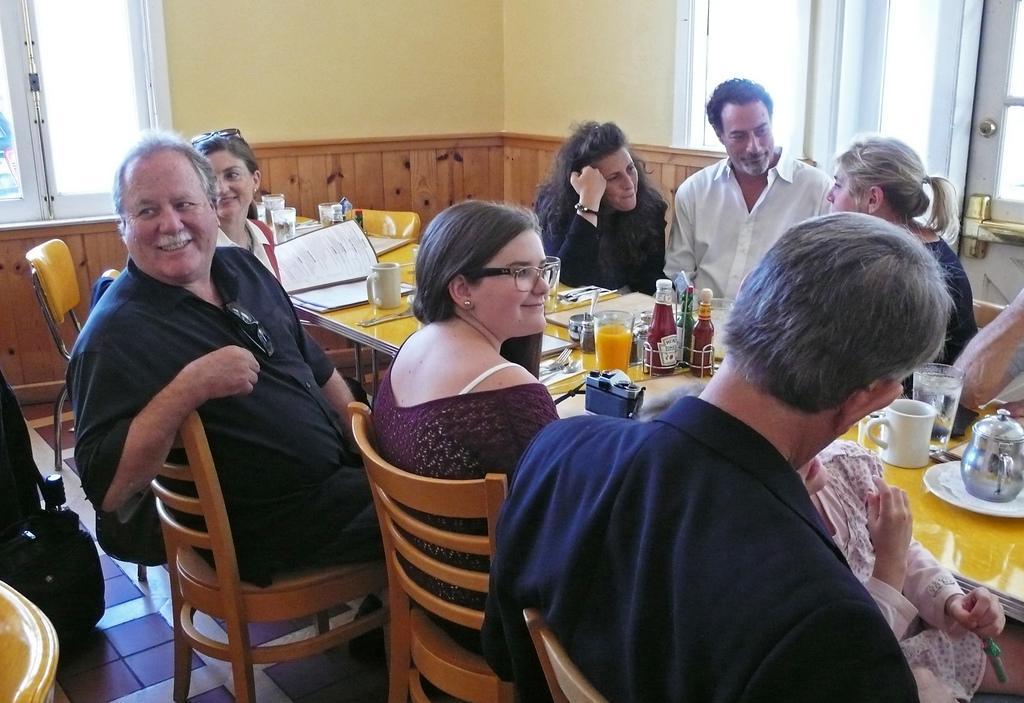Could you give a brief overview of what you see in this image? There are some people gathered at a table and talking to each other. 